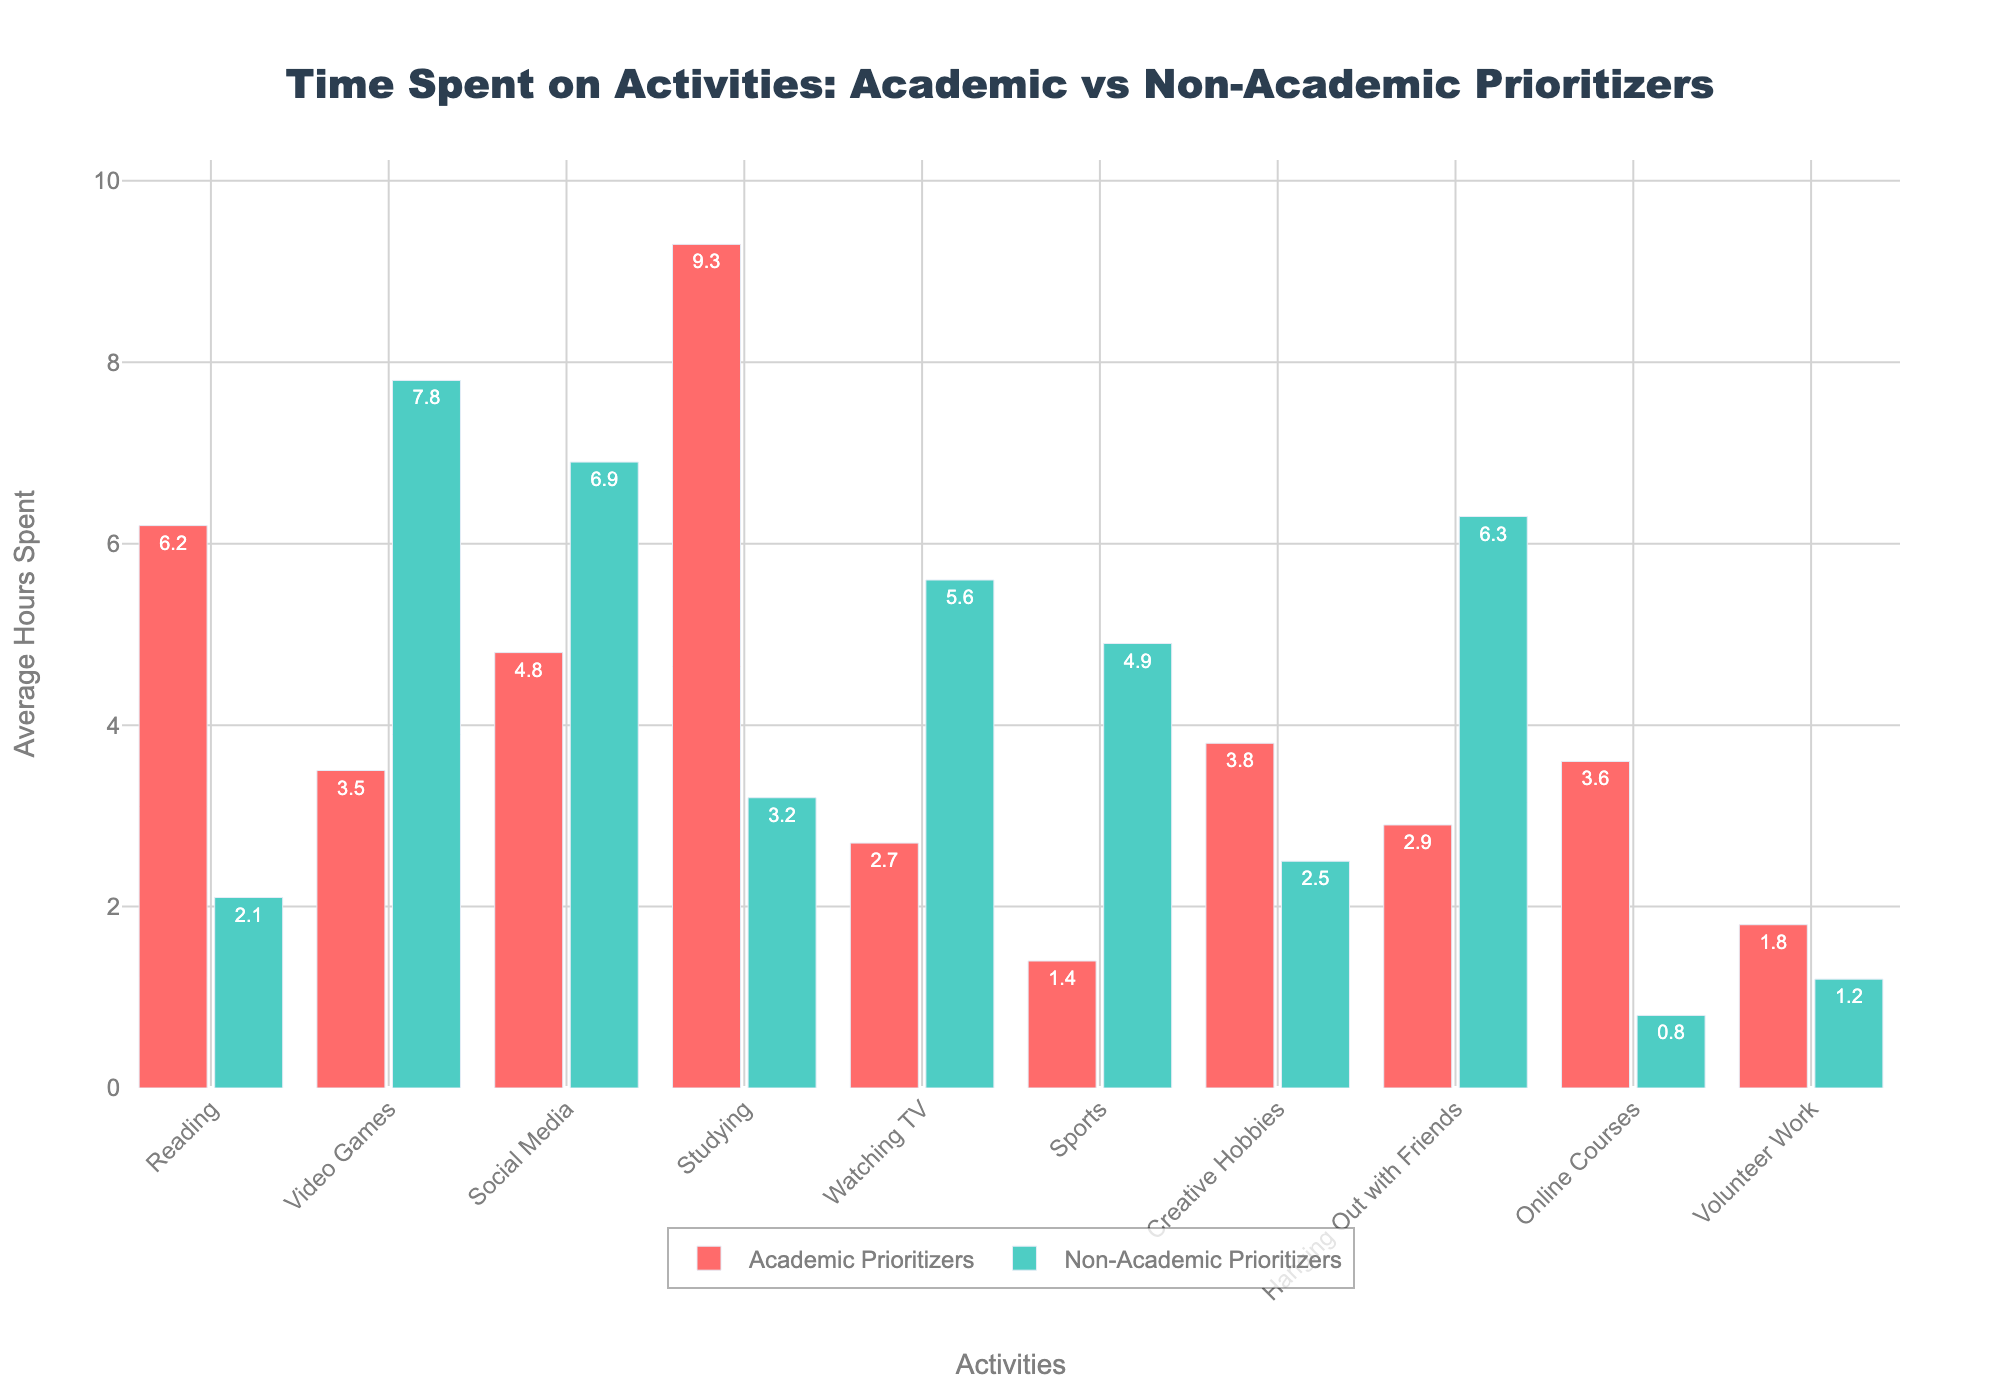Which activity has the greatest average hours spent by Academic Prioritizers? Look at the bar heights for Academic Prioritizers, the tallest bar represents Studying.
Answer: Studying Which activity has the least average hours spent by Non-Academic Prioritizers? Look at the smallest bar for Non-Academic Prioritizers, which is Online Courses.
Answer: Online Courses How many total hours do Academic Prioritizers spend on Social Media and Reading combined? Add average hours spent on Social Media (4.8) and Reading (6.2) for Academic Prioritizers: 4.8 + 6.2.
Answer: 11 What is the difference in average hours spent on Video Games between Academic and Non-Academic Prioritizers? Subtract average hours spent on Video Games by Academic Prioritizers (3.5) from Non-Academic Prioritizers (7.8): 7.8 - 3.5.
Answer: 4.3 Which group spends more average hours on Volunteer Work and by how much? Compare the heights of the bars for Volunteer Work: Academic Prioritizers (1.8) vs Non-Academic Prioritizers (1.2). Subtract and get the difference: 1.8 - 1.2.
Answer: Academic Prioritizers, 0.6 Which activities have Academic Prioritizers spending more than Non-Academic Prioritizers? Compare the bar heights for both groups across all activities. Academic Prioritizers spend more time on Reading, Studying, Creative Hobbies, and Online Courses.
Answer: Reading, Studying, Creative Hobbies, Online Courses How much longer do Non-Academic Prioritizers spend on Hanging Out with Friends compared to Academic Prioritizers? Subtract the average hours spent by Academic Prioritizers (2.9) from Non-Academic Prioritizers (6.3): 6.3 - 2.9.
Answer: 3.4 What is the total average time spent on Sports and Watching TV by Non-Academic Prioritizers? Add the average hours spent on Sports (4.9) and Watching TV (5.6) by Non-Academic Prioritizers: 4.9 + 5.6.
Answer: 10.5 